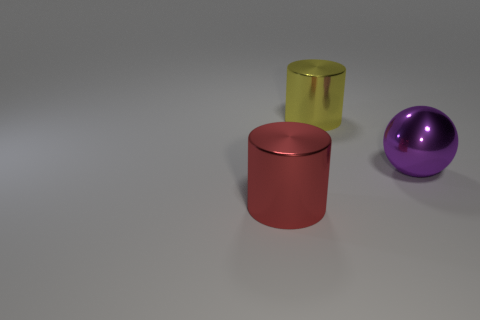There is a big shiny cylinder that is in front of the yellow metal thing right of the red metal cylinder; are there any large objects on the right side of it?
Your answer should be very brief. Yes. How many tiny objects are gray metal cubes or yellow metal cylinders?
Your answer should be compact. 0. Is there anything else that has the same color as the large metallic ball?
Offer a terse response. No. What color is the big metal cylinder that is on the left side of the metallic cylinder behind the cylinder in front of the big purple metal ball?
Keep it short and to the point. Red. The large metallic ball has what color?
Provide a short and direct response. Purple. There is another object that is the same shape as the yellow thing; what is it made of?
Provide a succinct answer. Metal. Does the yellow object have the same material as the purple thing?
Provide a succinct answer. Yes. There is a large cylinder that is to the right of the big metal thing in front of the big purple shiny ball; what color is it?
Give a very brief answer. Yellow. How many large red metal objects are the same shape as the big yellow shiny thing?
Your response must be concise. 1. What number of objects are cylinders in front of the large metal sphere or red cylinders to the left of the yellow metallic object?
Your response must be concise. 1. 